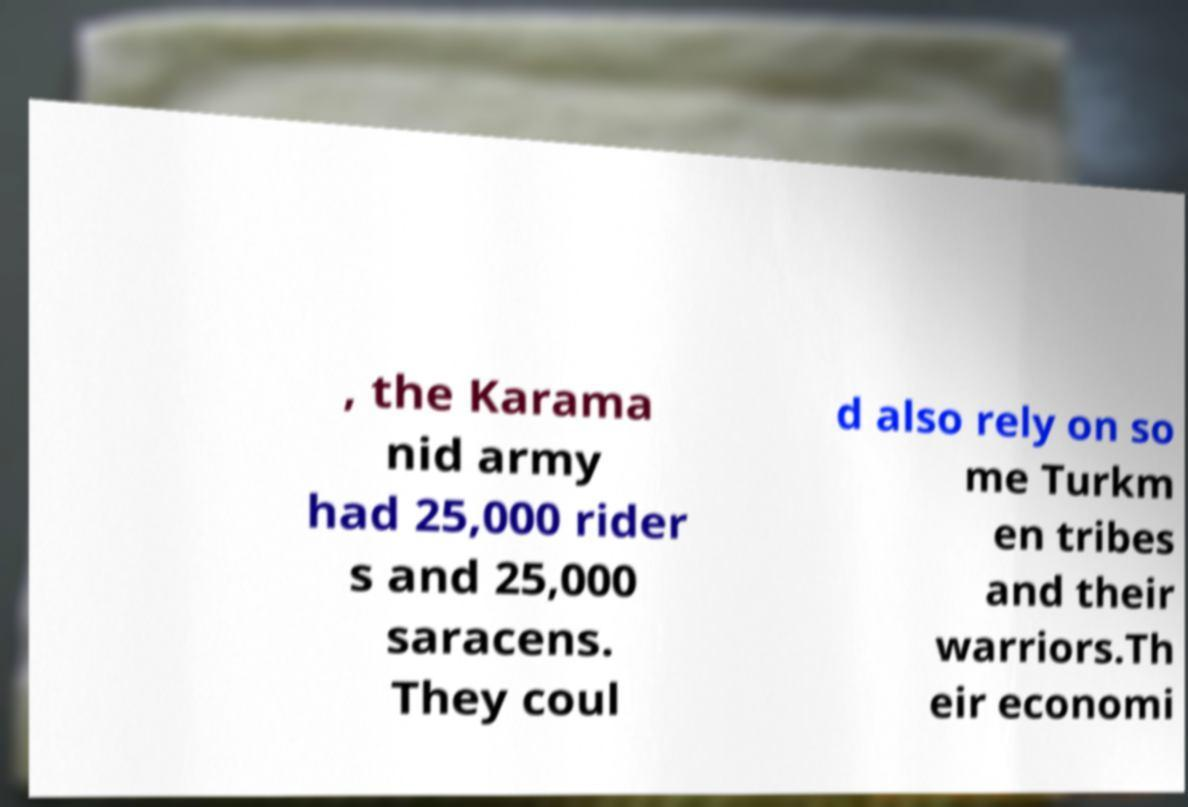Please read and relay the text visible in this image. What does it say? , the Karama nid army had 25,000 rider s and 25,000 saracens. They coul d also rely on so me Turkm en tribes and their warriors.Th eir economi 